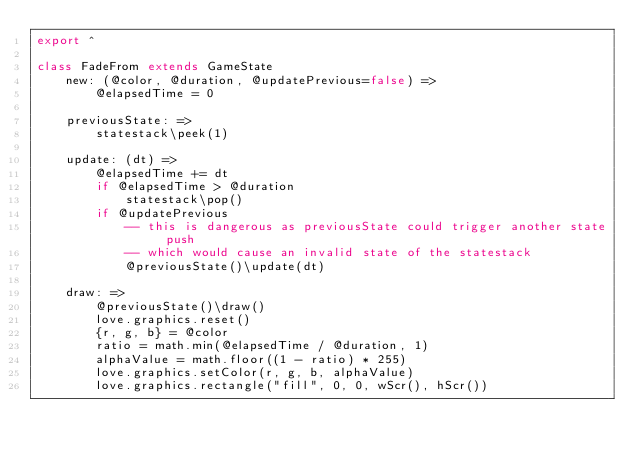<code> <loc_0><loc_0><loc_500><loc_500><_MoonScript_>export ^

class FadeFrom extends GameState
    new: (@color, @duration, @updatePrevious=false) =>
        @elapsedTime = 0

    previousState: =>
        statestack\peek(1)

    update: (dt) =>
        @elapsedTime += dt
        if @elapsedTime > @duration
            statestack\pop()
        if @updatePrevious
            -- this is dangerous as previousState could trigger another state push
            -- which would cause an invalid state of the statestack
            @previousState()\update(dt)

    draw: =>
        @previousState()\draw()
        love.graphics.reset()
        {r, g, b} = @color
        ratio = math.min(@elapsedTime / @duration, 1)
        alphaValue = math.floor((1 - ratio) * 255)
        love.graphics.setColor(r, g, b, alphaValue)
        love.graphics.rectangle("fill", 0, 0, wScr(), hScr())
</code> 